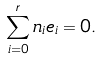<formula> <loc_0><loc_0><loc_500><loc_500>\sum _ { i = 0 } ^ { r } n _ { i } e _ { i } = 0 .</formula> 